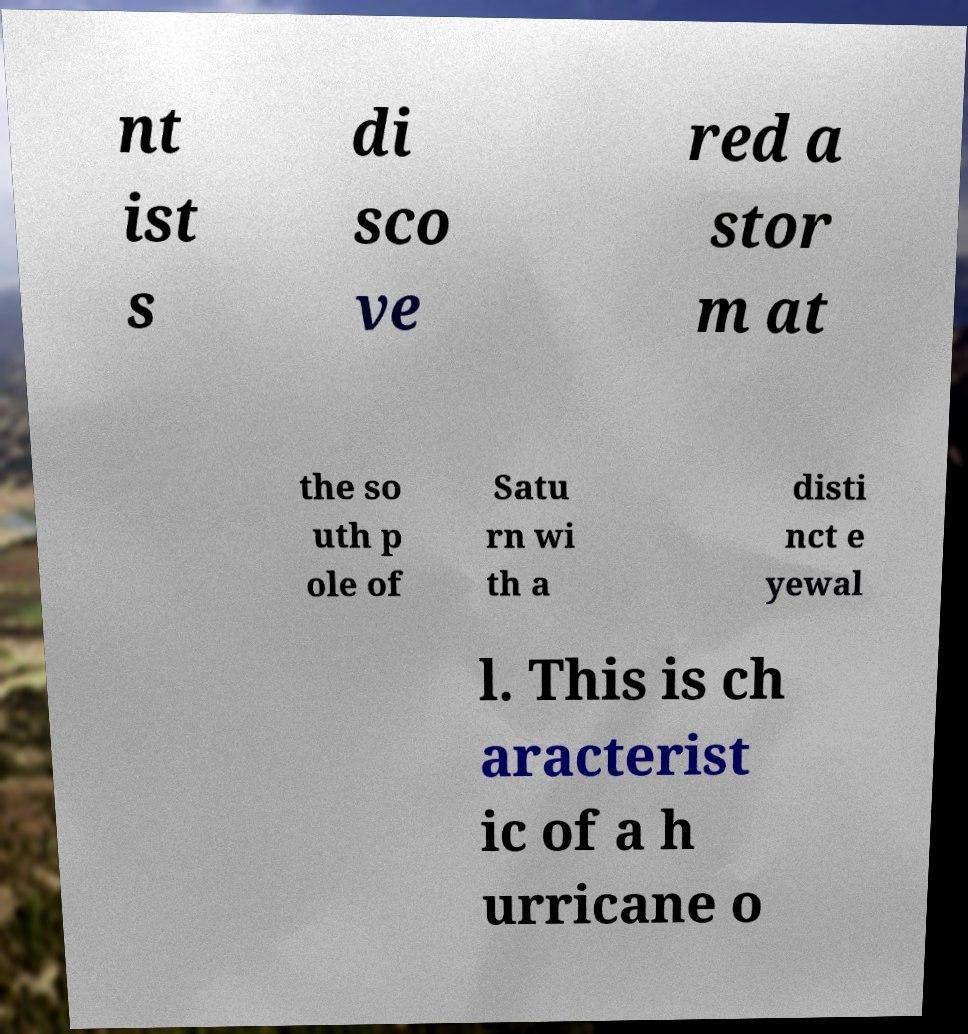What messages or text are displayed in this image? I need them in a readable, typed format. nt ist s di sco ve red a stor m at the so uth p ole of Satu rn wi th a disti nct e yewal l. This is ch aracterist ic of a h urricane o 